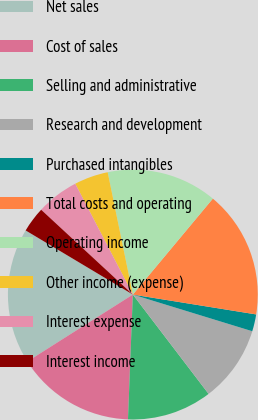Convert chart. <chart><loc_0><loc_0><loc_500><loc_500><pie_chart><fcel>Net sales<fcel>Cost of sales<fcel>Selling and administrative<fcel>Research and development<fcel>Purchased intangibles<fcel>Total costs and operating<fcel>Operating income<fcel>Other income (expense)<fcel>Interest expense<fcel>Interest income<nl><fcel>17.58%<fcel>15.38%<fcel>10.99%<fcel>9.89%<fcel>2.2%<fcel>16.48%<fcel>14.29%<fcel>4.4%<fcel>5.49%<fcel>3.3%<nl></chart> 